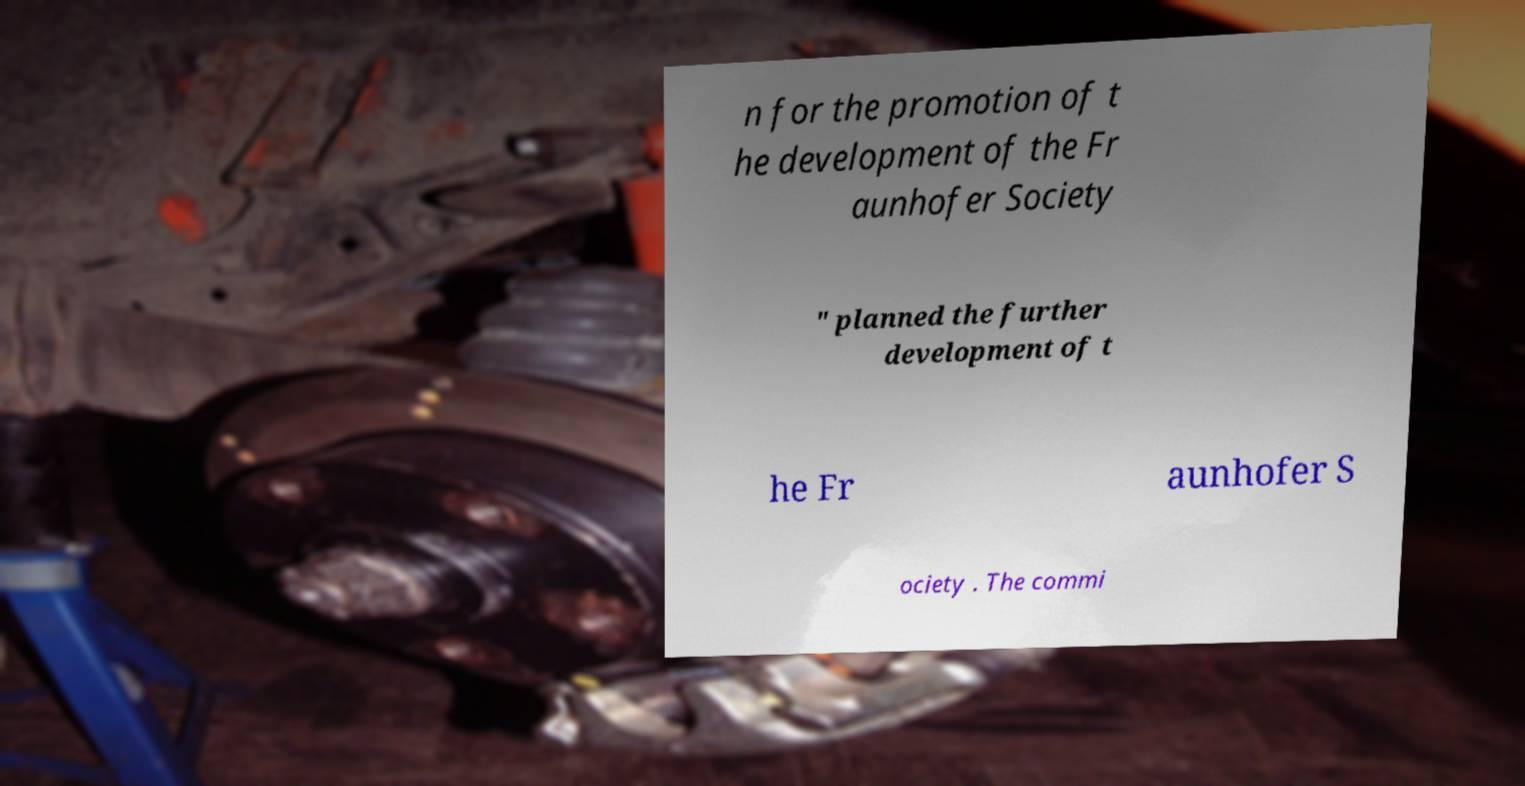Please identify and transcribe the text found in this image. n for the promotion of t he development of the Fr aunhofer Society " planned the further development of t he Fr aunhofer S ociety . The commi 